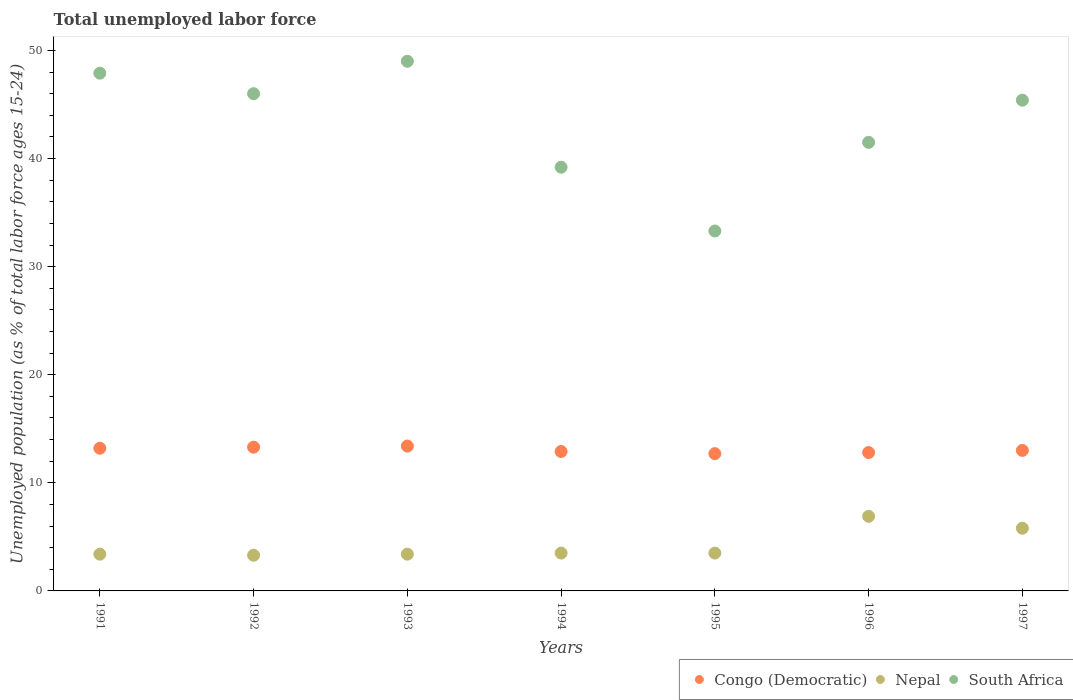How many different coloured dotlines are there?
Provide a succinct answer. 3. What is the percentage of unemployed population in in Congo (Democratic) in 1993?
Provide a short and direct response. 13.4. Across all years, what is the maximum percentage of unemployed population in in South Africa?
Offer a very short reply. 49. Across all years, what is the minimum percentage of unemployed population in in South Africa?
Give a very brief answer. 33.3. In which year was the percentage of unemployed population in in Congo (Democratic) maximum?
Provide a short and direct response. 1993. In which year was the percentage of unemployed population in in Nepal minimum?
Provide a short and direct response. 1992. What is the total percentage of unemployed population in in Nepal in the graph?
Make the answer very short. 29.8. What is the difference between the percentage of unemployed population in in Congo (Democratic) in 1991 and that in 1995?
Offer a terse response. 0.5. What is the difference between the percentage of unemployed population in in Nepal in 1992 and the percentage of unemployed population in in South Africa in 1996?
Your answer should be very brief. -38.2. What is the average percentage of unemployed population in in Congo (Democratic) per year?
Keep it short and to the point. 13.04. In the year 1991, what is the difference between the percentage of unemployed population in in Congo (Democratic) and percentage of unemployed population in in Nepal?
Offer a very short reply. 9.8. In how many years, is the percentage of unemployed population in in Nepal greater than 34 %?
Ensure brevity in your answer.  0. What is the ratio of the percentage of unemployed population in in South Africa in 1992 to that in 1993?
Ensure brevity in your answer.  0.94. Is the percentage of unemployed population in in Nepal in 1992 less than that in 1994?
Offer a terse response. Yes. What is the difference between the highest and the second highest percentage of unemployed population in in Nepal?
Your answer should be very brief. 1.1. What is the difference between the highest and the lowest percentage of unemployed population in in South Africa?
Provide a short and direct response. 15.7. In how many years, is the percentage of unemployed population in in Nepal greater than the average percentage of unemployed population in in Nepal taken over all years?
Offer a terse response. 2. Is it the case that in every year, the sum of the percentage of unemployed population in in Congo (Democratic) and percentage of unemployed population in in South Africa  is greater than the percentage of unemployed population in in Nepal?
Ensure brevity in your answer.  Yes. Is the percentage of unemployed population in in Nepal strictly less than the percentage of unemployed population in in Congo (Democratic) over the years?
Give a very brief answer. Yes. How many dotlines are there?
Your response must be concise. 3. Does the graph contain grids?
Your answer should be compact. No. Where does the legend appear in the graph?
Your response must be concise. Bottom right. What is the title of the graph?
Offer a very short reply. Total unemployed labor force. What is the label or title of the X-axis?
Ensure brevity in your answer.  Years. What is the label or title of the Y-axis?
Ensure brevity in your answer.  Unemployed population (as % of total labor force ages 15-24). What is the Unemployed population (as % of total labor force ages 15-24) in Congo (Democratic) in 1991?
Give a very brief answer. 13.2. What is the Unemployed population (as % of total labor force ages 15-24) of Nepal in 1991?
Provide a succinct answer. 3.4. What is the Unemployed population (as % of total labor force ages 15-24) of South Africa in 1991?
Offer a terse response. 47.9. What is the Unemployed population (as % of total labor force ages 15-24) in Congo (Democratic) in 1992?
Your answer should be compact. 13.3. What is the Unemployed population (as % of total labor force ages 15-24) of Nepal in 1992?
Your answer should be very brief. 3.3. What is the Unemployed population (as % of total labor force ages 15-24) of South Africa in 1992?
Ensure brevity in your answer.  46. What is the Unemployed population (as % of total labor force ages 15-24) of Congo (Democratic) in 1993?
Offer a very short reply. 13.4. What is the Unemployed population (as % of total labor force ages 15-24) of Nepal in 1993?
Your answer should be compact. 3.4. What is the Unemployed population (as % of total labor force ages 15-24) in Congo (Democratic) in 1994?
Your response must be concise. 12.9. What is the Unemployed population (as % of total labor force ages 15-24) in Nepal in 1994?
Keep it short and to the point. 3.5. What is the Unemployed population (as % of total labor force ages 15-24) in South Africa in 1994?
Keep it short and to the point. 39.2. What is the Unemployed population (as % of total labor force ages 15-24) in Congo (Democratic) in 1995?
Your response must be concise. 12.7. What is the Unemployed population (as % of total labor force ages 15-24) in South Africa in 1995?
Ensure brevity in your answer.  33.3. What is the Unemployed population (as % of total labor force ages 15-24) of Congo (Democratic) in 1996?
Provide a succinct answer. 12.8. What is the Unemployed population (as % of total labor force ages 15-24) of Nepal in 1996?
Ensure brevity in your answer.  6.9. What is the Unemployed population (as % of total labor force ages 15-24) in South Africa in 1996?
Provide a succinct answer. 41.5. What is the Unemployed population (as % of total labor force ages 15-24) in Nepal in 1997?
Provide a succinct answer. 5.8. What is the Unemployed population (as % of total labor force ages 15-24) of South Africa in 1997?
Make the answer very short. 45.4. Across all years, what is the maximum Unemployed population (as % of total labor force ages 15-24) in Congo (Democratic)?
Your answer should be compact. 13.4. Across all years, what is the maximum Unemployed population (as % of total labor force ages 15-24) of Nepal?
Keep it short and to the point. 6.9. Across all years, what is the minimum Unemployed population (as % of total labor force ages 15-24) of Congo (Democratic)?
Your response must be concise. 12.7. Across all years, what is the minimum Unemployed population (as % of total labor force ages 15-24) in Nepal?
Your answer should be very brief. 3.3. Across all years, what is the minimum Unemployed population (as % of total labor force ages 15-24) in South Africa?
Your response must be concise. 33.3. What is the total Unemployed population (as % of total labor force ages 15-24) in Congo (Democratic) in the graph?
Keep it short and to the point. 91.3. What is the total Unemployed population (as % of total labor force ages 15-24) in Nepal in the graph?
Offer a terse response. 29.8. What is the total Unemployed population (as % of total labor force ages 15-24) of South Africa in the graph?
Your response must be concise. 302.3. What is the difference between the Unemployed population (as % of total labor force ages 15-24) of Congo (Democratic) in 1991 and that in 1992?
Offer a terse response. -0.1. What is the difference between the Unemployed population (as % of total labor force ages 15-24) of South Africa in 1991 and that in 1992?
Provide a succinct answer. 1.9. What is the difference between the Unemployed population (as % of total labor force ages 15-24) of Nepal in 1991 and that in 1993?
Your answer should be very brief. 0. What is the difference between the Unemployed population (as % of total labor force ages 15-24) of Congo (Democratic) in 1991 and that in 1995?
Offer a very short reply. 0.5. What is the difference between the Unemployed population (as % of total labor force ages 15-24) in Nepal in 1991 and that in 1995?
Ensure brevity in your answer.  -0.1. What is the difference between the Unemployed population (as % of total labor force ages 15-24) in Congo (Democratic) in 1991 and that in 1996?
Make the answer very short. 0.4. What is the difference between the Unemployed population (as % of total labor force ages 15-24) in South Africa in 1991 and that in 1996?
Ensure brevity in your answer.  6.4. What is the difference between the Unemployed population (as % of total labor force ages 15-24) of Congo (Democratic) in 1991 and that in 1997?
Your answer should be very brief. 0.2. What is the difference between the Unemployed population (as % of total labor force ages 15-24) in South Africa in 1991 and that in 1997?
Give a very brief answer. 2.5. What is the difference between the Unemployed population (as % of total labor force ages 15-24) of Congo (Democratic) in 1992 and that in 1993?
Provide a succinct answer. -0.1. What is the difference between the Unemployed population (as % of total labor force ages 15-24) of Congo (Democratic) in 1992 and that in 1994?
Your answer should be compact. 0.4. What is the difference between the Unemployed population (as % of total labor force ages 15-24) in South Africa in 1992 and that in 1994?
Ensure brevity in your answer.  6.8. What is the difference between the Unemployed population (as % of total labor force ages 15-24) of Congo (Democratic) in 1992 and that in 1995?
Offer a terse response. 0.6. What is the difference between the Unemployed population (as % of total labor force ages 15-24) in Nepal in 1992 and that in 1995?
Your response must be concise. -0.2. What is the difference between the Unemployed population (as % of total labor force ages 15-24) of South Africa in 1992 and that in 1995?
Provide a succinct answer. 12.7. What is the difference between the Unemployed population (as % of total labor force ages 15-24) of Nepal in 1992 and that in 1996?
Your response must be concise. -3.6. What is the difference between the Unemployed population (as % of total labor force ages 15-24) in South Africa in 1992 and that in 1996?
Provide a short and direct response. 4.5. What is the difference between the Unemployed population (as % of total labor force ages 15-24) in South Africa in 1992 and that in 1997?
Your answer should be compact. 0.6. What is the difference between the Unemployed population (as % of total labor force ages 15-24) of Congo (Democratic) in 1993 and that in 1994?
Your answer should be very brief. 0.5. What is the difference between the Unemployed population (as % of total labor force ages 15-24) in Nepal in 1993 and that in 1994?
Offer a very short reply. -0.1. What is the difference between the Unemployed population (as % of total labor force ages 15-24) of South Africa in 1993 and that in 1994?
Give a very brief answer. 9.8. What is the difference between the Unemployed population (as % of total labor force ages 15-24) of Congo (Democratic) in 1993 and that in 1995?
Your response must be concise. 0.7. What is the difference between the Unemployed population (as % of total labor force ages 15-24) in Nepal in 1993 and that in 1995?
Provide a short and direct response. -0.1. What is the difference between the Unemployed population (as % of total labor force ages 15-24) of Congo (Democratic) in 1993 and that in 1996?
Your response must be concise. 0.6. What is the difference between the Unemployed population (as % of total labor force ages 15-24) of South Africa in 1993 and that in 1996?
Offer a very short reply. 7.5. What is the difference between the Unemployed population (as % of total labor force ages 15-24) of Nepal in 1994 and that in 1995?
Make the answer very short. 0. What is the difference between the Unemployed population (as % of total labor force ages 15-24) in Nepal in 1994 and that in 1996?
Keep it short and to the point. -3.4. What is the difference between the Unemployed population (as % of total labor force ages 15-24) of Congo (Democratic) in 1994 and that in 1997?
Offer a very short reply. -0.1. What is the difference between the Unemployed population (as % of total labor force ages 15-24) of South Africa in 1994 and that in 1997?
Keep it short and to the point. -6.2. What is the difference between the Unemployed population (as % of total labor force ages 15-24) of Congo (Democratic) in 1995 and that in 1996?
Provide a succinct answer. -0.1. What is the difference between the Unemployed population (as % of total labor force ages 15-24) in Nepal in 1995 and that in 1996?
Your answer should be very brief. -3.4. What is the difference between the Unemployed population (as % of total labor force ages 15-24) of Congo (Democratic) in 1995 and that in 1997?
Ensure brevity in your answer.  -0.3. What is the difference between the Unemployed population (as % of total labor force ages 15-24) in Nepal in 1995 and that in 1997?
Your answer should be compact. -2.3. What is the difference between the Unemployed population (as % of total labor force ages 15-24) of Nepal in 1996 and that in 1997?
Your answer should be very brief. 1.1. What is the difference between the Unemployed population (as % of total labor force ages 15-24) of South Africa in 1996 and that in 1997?
Offer a terse response. -3.9. What is the difference between the Unemployed population (as % of total labor force ages 15-24) in Congo (Democratic) in 1991 and the Unemployed population (as % of total labor force ages 15-24) in Nepal in 1992?
Provide a succinct answer. 9.9. What is the difference between the Unemployed population (as % of total labor force ages 15-24) of Congo (Democratic) in 1991 and the Unemployed population (as % of total labor force ages 15-24) of South Africa in 1992?
Provide a succinct answer. -32.8. What is the difference between the Unemployed population (as % of total labor force ages 15-24) in Nepal in 1991 and the Unemployed population (as % of total labor force ages 15-24) in South Africa in 1992?
Your answer should be compact. -42.6. What is the difference between the Unemployed population (as % of total labor force ages 15-24) in Congo (Democratic) in 1991 and the Unemployed population (as % of total labor force ages 15-24) in South Africa in 1993?
Your answer should be very brief. -35.8. What is the difference between the Unemployed population (as % of total labor force ages 15-24) in Nepal in 1991 and the Unemployed population (as % of total labor force ages 15-24) in South Africa in 1993?
Offer a very short reply. -45.6. What is the difference between the Unemployed population (as % of total labor force ages 15-24) of Congo (Democratic) in 1991 and the Unemployed population (as % of total labor force ages 15-24) of Nepal in 1994?
Keep it short and to the point. 9.7. What is the difference between the Unemployed population (as % of total labor force ages 15-24) of Nepal in 1991 and the Unemployed population (as % of total labor force ages 15-24) of South Africa in 1994?
Keep it short and to the point. -35.8. What is the difference between the Unemployed population (as % of total labor force ages 15-24) in Congo (Democratic) in 1991 and the Unemployed population (as % of total labor force ages 15-24) in South Africa in 1995?
Your response must be concise. -20.1. What is the difference between the Unemployed population (as % of total labor force ages 15-24) of Nepal in 1991 and the Unemployed population (as % of total labor force ages 15-24) of South Africa in 1995?
Offer a very short reply. -29.9. What is the difference between the Unemployed population (as % of total labor force ages 15-24) of Congo (Democratic) in 1991 and the Unemployed population (as % of total labor force ages 15-24) of Nepal in 1996?
Your response must be concise. 6.3. What is the difference between the Unemployed population (as % of total labor force ages 15-24) of Congo (Democratic) in 1991 and the Unemployed population (as % of total labor force ages 15-24) of South Africa in 1996?
Provide a succinct answer. -28.3. What is the difference between the Unemployed population (as % of total labor force ages 15-24) in Nepal in 1991 and the Unemployed population (as % of total labor force ages 15-24) in South Africa in 1996?
Provide a succinct answer. -38.1. What is the difference between the Unemployed population (as % of total labor force ages 15-24) of Congo (Democratic) in 1991 and the Unemployed population (as % of total labor force ages 15-24) of South Africa in 1997?
Keep it short and to the point. -32.2. What is the difference between the Unemployed population (as % of total labor force ages 15-24) in Nepal in 1991 and the Unemployed population (as % of total labor force ages 15-24) in South Africa in 1997?
Your answer should be very brief. -42. What is the difference between the Unemployed population (as % of total labor force ages 15-24) in Congo (Democratic) in 1992 and the Unemployed population (as % of total labor force ages 15-24) in Nepal in 1993?
Give a very brief answer. 9.9. What is the difference between the Unemployed population (as % of total labor force ages 15-24) in Congo (Democratic) in 1992 and the Unemployed population (as % of total labor force ages 15-24) in South Africa in 1993?
Offer a terse response. -35.7. What is the difference between the Unemployed population (as % of total labor force ages 15-24) of Nepal in 1992 and the Unemployed population (as % of total labor force ages 15-24) of South Africa in 1993?
Give a very brief answer. -45.7. What is the difference between the Unemployed population (as % of total labor force ages 15-24) of Congo (Democratic) in 1992 and the Unemployed population (as % of total labor force ages 15-24) of Nepal in 1994?
Your answer should be very brief. 9.8. What is the difference between the Unemployed population (as % of total labor force ages 15-24) of Congo (Democratic) in 1992 and the Unemployed population (as % of total labor force ages 15-24) of South Africa in 1994?
Make the answer very short. -25.9. What is the difference between the Unemployed population (as % of total labor force ages 15-24) of Nepal in 1992 and the Unemployed population (as % of total labor force ages 15-24) of South Africa in 1994?
Provide a short and direct response. -35.9. What is the difference between the Unemployed population (as % of total labor force ages 15-24) of Congo (Democratic) in 1992 and the Unemployed population (as % of total labor force ages 15-24) of South Africa in 1995?
Ensure brevity in your answer.  -20. What is the difference between the Unemployed population (as % of total labor force ages 15-24) of Nepal in 1992 and the Unemployed population (as % of total labor force ages 15-24) of South Africa in 1995?
Keep it short and to the point. -30. What is the difference between the Unemployed population (as % of total labor force ages 15-24) in Congo (Democratic) in 1992 and the Unemployed population (as % of total labor force ages 15-24) in South Africa in 1996?
Ensure brevity in your answer.  -28.2. What is the difference between the Unemployed population (as % of total labor force ages 15-24) of Nepal in 1992 and the Unemployed population (as % of total labor force ages 15-24) of South Africa in 1996?
Ensure brevity in your answer.  -38.2. What is the difference between the Unemployed population (as % of total labor force ages 15-24) in Congo (Democratic) in 1992 and the Unemployed population (as % of total labor force ages 15-24) in South Africa in 1997?
Give a very brief answer. -32.1. What is the difference between the Unemployed population (as % of total labor force ages 15-24) of Nepal in 1992 and the Unemployed population (as % of total labor force ages 15-24) of South Africa in 1997?
Your answer should be compact. -42.1. What is the difference between the Unemployed population (as % of total labor force ages 15-24) of Congo (Democratic) in 1993 and the Unemployed population (as % of total labor force ages 15-24) of Nepal in 1994?
Your answer should be very brief. 9.9. What is the difference between the Unemployed population (as % of total labor force ages 15-24) of Congo (Democratic) in 1993 and the Unemployed population (as % of total labor force ages 15-24) of South Africa in 1994?
Provide a succinct answer. -25.8. What is the difference between the Unemployed population (as % of total labor force ages 15-24) in Nepal in 1993 and the Unemployed population (as % of total labor force ages 15-24) in South Africa in 1994?
Keep it short and to the point. -35.8. What is the difference between the Unemployed population (as % of total labor force ages 15-24) in Congo (Democratic) in 1993 and the Unemployed population (as % of total labor force ages 15-24) in Nepal in 1995?
Your answer should be very brief. 9.9. What is the difference between the Unemployed population (as % of total labor force ages 15-24) in Congo (Democratic) in 1993 and the Unemployed population (as % of total labor force ages 15-24) in South Africa in 1995?
Offer a very short reply. -19.9. What is the difference between the Unemployed population (as % of total labor force ages 15-24) of Nepal in 1993 and the Unemployed population (as % of total labor force ages 15-24) of South Africa in 1995?
Offer a terse response. -29.9. What is the difference between the Unemployed population (as % of total labor force ages 15-24) of Congo (Democratic) in 1993 and the Unemployed population (as % of total labor force ages 15-24) of South Africa in 1996?
Give a very brief answer. -28.1. What is the difference between the Unemployed population (as % of total labor force ages 15-24) of Nepal in 1993 and the Unemployed population (as % of total labor force ages 15-24) of South Africa in 1996?
Your response must be concise. -38.1. What is the difference between the Unemployed population (as % of total labor force ages 15-24) in Congo (Democratic) in 1993 and the Unemployed population (as % of total labor force ages 15-24) in Nepal in 1997?
Provide a succinct answer. 7.6. What is the difference between the Unemployed population (as % of total labor force ages 15-24) in Congo (Democratic) in 1993 and the Unemployed population (as % of total labor force ages 15-24) in South Africa in 1997?
Your response must be concise. -32. What is the difference between the Unemployed population (as % of total labor force ages 15-24) of Nepal in 1993 and the Unemployed population (as % of total labor force ages 15-24) of South Africa in 1997?
Ensure brevity in your answer.  -42. What is the difference between the Unemployed population (as % of total labor force ages 15-24) in Congo (Democratic) in 1994 and the Unemployed population (as % of total labor force ages 15-24) in South Africa in 1995?
Provide a short and direct response. -20.4. What is the difference between the Unemployed population (as % of total labor force ages 15-24) in Nepal in 1994 and the Unemployed population (as % of total labor force ages 15-24) in South Africa in 1995?
Give a very brief answer. -29.8. What is the difference between the Unemployed population (as % of total labor force ages 15-24) of Congo (Democratic) in 1994 and the Unemployed population (as % of total labor force ages 15-24) of Nepal in 1996?
Keep it short and to the point. 6. What is the difference between the Unemployed population (as % of total labor force ages 15-24) in Congo (Democratic) in 1994 and the Unemployed population (as % of total labor force ages 15-24) in South Africa in 1996?
Your answer should be very brief. -28.6. What is the difference between the Unemployed population (as % of total labor force ages 15-24) of Nepal in 1994 and the Unemployed population (as % of total labor force ages 15-24) of South Africa in 1996?
Offer a terse response. -38. What is the difference between the Unemployed population (as % of total labor force ages 15-24) of Congo (Democratic) in 1994 and the Unemployed population (as % of total labor force ages 15-24) of South Africa in 1997?
Give a very brief answer. -32.5. What is the difference between the Unemployed population (as % of total labor force ages 15-24) in Nepal in 1994 and the Unemployed population (as % of total labor force ages 15-24) in South Africa in 1997?
Offer a very short reply. -41.9. What is the difference between the Unemployed population (as % of total labor force ages 15-24) in Congo (Democratic) in 1995 and the Unemployed population (as % of total labor force ages 15-24) in Nepal in 1996?
Provide a succinct answer. 5.8. What is the difference between the Unemployed population (as % of total labor force ages 15-24) of Congo (Democratic) in 1995 and the Unemployed population (as % of total labor force ages 15-24) of South Africa in 1996?
Offer a very short reply. -28.8. What is the difference between the Unemployed population (as % of total labor force ages 15-24) in Nepal in 1995 and the Unemployed population (as % of total labor force ages 15-24) in South Africa in 1996?
Provide a short and direct response. -38. What is the difference between the Unemployed population (as % of total labor force ages 15-24) of Congo (Democratic) in 1995 and the Unemployed population (as % of total labor force ages 15-24) of Nepal in 1997?
Provide a short and direct response. 6.9. What is the difference between the Unemployed population (as % of total labor force ages 15-24) of Congo (Democratic) in 1995 and the Unemployed population (as % of total labor force ages 15-24) of South Africa in 1997?
Offer a terse response. -32.7. What is the difference between the Unemployed population (as % of total labor force ages 15-24) of Nepal in 1995 and the Unemployed population (as % of total labor force ages 15-24) of South Africa in 1997?
Give a very brief answer. -41.9. What is the difference between the Unemployed population (as % of total labor force ages 15-24) of Congo (Democratic) in 1996 and the Unemployed population (as % of total labor force ages 15-24) of South Africa in 1997?
Provide a short and direct response. -32.6. What is the difference between the Unemployed population (as % of total labor force ages 15-24) in Nepal in 1996 and the Unemployed population (as % of total labor force ages 15-24) in South Africa in 1997?
Your response must be concise. -38.5. What is the average Unemployed population (as % of total labor force ages 15-24) of Congo (Democratic) per year?
Your answer should be very brief. 13.04. What is the average Unemployed population (as % of total labor force ages 15-24) in Nepal per year?
Your answer should be very brief. 4.26. What is the average Unemployed population (as % of total labor force ages 15-24) in South Africa per year?
Ensure brevity in your answer.  43.19. In the year 1991, what is the difference between the Unemployed population (as % of total labor force ages 15-24) in Congo (Democratic) and Unemployed population (as % of total labor force ages 15-24) in Nepal?
Your answer should be compact. 9.8. In the year 1991, what is the difference between the Unemployed population (as % of total labor force ages 15-24) of Congo (Democratic) and Unemployed population (as % of total labor force ages 15-24) of South Africa?
Offer a terse response. -34.7. In the year 1991, what is the difference between the Unemployed population (as % of total labor force ages 15-24) of Nepal and Unemployed population (as % of total labor force ages 15-24) of South Africa?
Your response must be concise. -44.5. In the year 1992, what is the difference between the Unemployed population (as % of total labor force ages 15-24) in Congo (Democratic) and Unemployed population (as % of total labor force ages 15-24) in Nepal?
Offer a very short reply. 10. In the year 1992, what is the difference between the Unemployed population (as % of total labor force ages 15-24) of Congo (Democratic) and Unemployed population (as % of total labor force ages 15-24) of South Africa?
Ensure brevity in your answer.  -32.7. In the year 1992, what is the difference between the Unemployed population (as % of total labor force ages 15-24) of Nepal and Unemployed population (as % of total labor force ages 15-24) of South Africa?
Provide a succinct answer. -42.7. In the year 1993, what is the difference between the Unemployed population (as % of total labor force ages 15-24) of Congo (Democratic) and Unemployed population (as % of total labor force ages 15-24) of South Africa?
Offer a terse response. -35.6. In the year 1993, what is the difference between the Unemployed population (as % of total labor force ages 15-24) of Nepal and Unemployed population (as % of total labor force ages 15-24) of South Africa?
Offer a very short reply. -45.6. In the year 1994, what is the difference between the Unemployed population (as % of total labor force ages 15-24) of Congo (Democratic) and Unemployed population (as % of total labor force ages 15-24) of Nepal?
Your answer should be very brief. 9.4. In the year 1994, what is the difference between the Unemployed population (as % of total labor force ages 15-24) of Congo (Democratic) and Unemployed population (as % of total labor force ages 15-24) of South Africa?
Your answer should be compact. -26.3. In the year 1994, what is the difference between the Unemployed population (as % of total labor force ages 15-24) of Nepal and Unemployed population (as % of total labor force ages 15-24) of South Africa?
Keep it short and to the point. -35.7. In the year 1995, what is the difference between the Unemployed population (as % of total labor force ages 15-24) of Congo (Democratic) and Unemployed population (as % of total labor force ages 15-24) of Nepal?
Your answer should be very brief. 9.2. In the year 1995, what is the difference between the Unemployed population (as % of total labor force ages 15-24) in Congo (Democratic) and Unemployed population (as % of total labor force ages 15-24) in South Africa?
Provide a succinct answer. -20.6. In the year 1995, what is the difference between the Unemployed population (as % of total labor force ages 15-24) of Nepal and Unemployed population (as % of total labor force ages 15-24) of South Africa?
Give a very brief answer. -29.8. In the year 1996, what is the difference between the Unemployed population (as % of total labor force ages 15-24) in Congo (Democratic) and Unemployed population (as % of total labor force ages 15-24) in Nepal?
Ensure brevity in your answer.  5.9. In the year 1996, what is the difference between the Unemployed population (as % of total labor force ages 15-24) of Congo (Democratic) and Unemployed population (as % of total labor force ages 15-24) of South Africa?
Make the answer very short. -28.7. In the year 1996, what is the difference between the Unemployed population (as % of total labor force ages 15-24) of Nepal and Unemployed population (as % of total labor force ages 15-24) of South Africa?
Make the answer very short. -34.6. In the year 1997, what is the difference between the Unemployed population (as % of total labor force ages 15-24) in Congo (Democratic) and Unemployed population (as % of total labor force ages 15-24) in South Africa?
Offer a terse response. -32.4. In the year 1997, what is the difference between the Unemployed population (as % of total labor force ages 15-24) in Nepal and Unemployed population (as % of total labor force ages 15-24) in South Africa?
Provide a short and direct response. -39.6. What is the ratio of the Unemployed population (as % of total labor force ages 15-24) of Nepal in 1991 to that in 1992?
Offer a very short reply. 1.03. What is the ratio of the Unemployed population (as % of total labor force ages 15-24) of South Africa in 1991 to that in 1992?
Your answer should be compact. 1.04. What is the ratio of the Unemployed population (as % of total labor force ages 15-24) in Congo (Democratic) in 1991 to that in 1993?
Give a very brief answer. 0.99. What is the ratio of the Unemployed population (as % of total labor force ages 15-24) in South Africa in 1991 to that in 1993?
Give a very brief answer. 0.98. What is the ratio of the Unemployed population (as % of total labor force ages 15-24) of Congo (Democratic) in 1991 to that in 1994?
Make the answer very short. 1.02. What is the ratio of the Unemployed population (as % of total labor force ages 15-24) in Nepal in 1991 to that in 1994?
Offer a very short reply. 0.97. What is the ratio of the Unemployed population (as % of total labor force ages 15-24) in South Africa in 1991 to that in 1994?
Ensure brevity in your answer.  1.22. What is the ratio of the Unemployed population (as % of total labor force ages 15-24) of Congo (Democratic) in 1991 to that in 1995?
Keep it short and to the point. 1.04. What is the ratio of the Unemployed population (as % of total labor force ages 15-24) of Nepal in 1991 to that in 1995?
Your answer should be very brief. 0.97. What is the ratio of the Unemployed population (as % of total labor force ages 15-24) of South Africa in 1991 to that in 1995?
Offer a very short reply. 1.44. What is the ratio of the Unemployed population (as % of total labor force ages 15-24) in Congo (Democratic) in 1991 to that in 1996?
Give a very brief answer. 1.03. What is the ratio of the Unemployed population (as % of total labor force ages 15-24) of Nepal in 1991 to that in 1996?
Your answer should be very brief. 0.49. What is the ratio of the Unemployed population (as % of total labor force ages 15-24) in South Africa in 1991 to that in 1996?
Keep it short and to the point. 1.15. What is the ratio of the Unemployed population (as % of total labor force ages 15-24) in Congo (Democratic) in 1991 to that in 1997?
Provide a succinct answer. 1.02. What is the ratio of the Unemployed population (as % of total labor force ages 15-24) in Nepal in 1991 to that in 1997?
Offer a very short reply. 0.59. What is the ratio of the Unemployed population (as % of total labor force ages 15-24) of South Africa in 1991 to that in 1997?
Make the answer very short. 1.06. What is the ratio of the Unemployed population (as % of total labor force ages 15-24) in Nepal in 1992 to that in 1993?
Give a very brief answer. 0.97. What is the ratio of the Unemployed population (as % of total labor force ages 15-24) of South Africa in 1992 to that in 1993?
Ensure brevity in your answer.  0.94. What is the ratio of the Unemployed population (as % of total labor force ages 15-24) in Congo (Democratic) in 1992 to that in 1994?
Your answer should be very brief. 1.03. What is the ratio of the Unemployed population (as % of total labor force ages 15-24) in Nepal in 1992 to that in 1994?
Your answer should be compact. 0.94. What is the ratio of the Unemployed population (as % of total labor force ages 15-24) in South Africa in 1992 to that in 1994?
Ensure brevity in your answer.  1.17. What is the ratio of the Unemployed population (as % of total labor force ages 15-24) in Congo (Democratic) in 1992 to that in 1995?
Ensure brevity in your answer.  1.05. What is the ratio of the Unemployed population (as % of total labor force ages 15-24) in Nepal in 1992 to that in 1995?
Keep it short and to the point. 0.94. What is the ratio of the Unemployed population (as % of total labor force ages 15-24) in South Africa in 1992 to that in 1995?
Give a very brief answer. 1.38. What is the ratio of the Unemployed population (as % of total labor force ages 15-24) in Congo (Democratic) in 1992 to that in 1996?
Your response must be concise. 1.04. What is the ratio of the Unemployed population (as % of total labor force ages 15-24) in Nepal in 1992 to that in 1996?
Keep it short and to the point. 0.48. What is the ratio of the Unemployed population (as % of total labor force ages 15-24) in South Africa in 1992 to that in 1996?
Make the answer very short. 1.11. What is the ratio of the Unemployed population (as % of total labor force ages 15-24) in Congo (Democratic) in 1992 to that in 1997?
Give a very brief answer. 1.02. What is the ratio of the Unemployed population (as % of total labor force ages 15-24) of Nepal in 1992 to that in 1997?
Your answer should be very brief. 0.57. What is the ratio of the Unemployed population (as % of total labor force ages 15-24) of South Africa in 1992 to that in 1997?
Offer a very short reply. 1.01. What is the ratio of the Unemployed population (as % of total labor force ages 15-24) of Congo (Democratic) in 1993 to that in 1994?
Provide a short and direct response. 1.04. What is the ratio of the Unemployed population (as % of total labor force ages 15-24) in Nepal in 1993 to that in 1994?
Give a very brief answer. 0.97. What is the ratio of the Unemployed population (as % of total labor force ages 15-24) in Congo (Democratic) in 1993 to that in 1995?
Ensure brevity in your answer.  1.06. What is the ratio of the Unemployed population (as % of total labor force ages 15-24) of Nepal in 1993 to that in 1995?
Provide a succinct answer. 0.97. What is the ratio of the Unemployed population (as % of total labor force ages 15-24) in South Africa in 1993 to that in 1995?
Your answer should be very brief. 1.47. What is the ratio of the Unemployed population (as % of total labor force ages 15-24) of Congo (Democratic) in 1993 to that in 1996?
Keep it short and to the point. 1.05. What is the ratio of the Unemployed population (as % of total labor force ages 15-24) in Nepal in 1993 to that in 1996?
Give a very brief answer. 0.49. What is the ratio of the Unemployed population (as % of total labor force ages 15-24) in South Africa in 1993 to that in 1996?
Provide a short and direct response. 1.18. What is the ratio of the Unemployed population (as % of total labor force ages 15-24) of Congo (Democratic) in 1993 to that in 1997?
Offer a very short reply. 1.03. What is the ratio of the Unemployed population (as % of total labor force ages 15-24) of Nepal in 1993 to that in 1997?
Your answer should be very brief. 0.59. What is the ratio of the Unemployed population (as % of total labor force ages 15-24) in South Africa in 1993 to that in 1997?
Make the answer very short. 1.08. What is the ratio of the Unemployed population (as % of total labor force ages 15-24) in Congo (Democratic) in 1994 to that in 1995?
Keep it short and to the point. 1.02. What is the ratio of the Unemployed population (as % of total labor force ages 15-24) of South Africa in 1994 to that in 1995?
Provide a succinct answer. 1.18. What is the ratio of the Unemployed population (as % of total labor force ages 15-24) in Nepal in 1994 to that in 1996?
Offer a very short reply. 0.51. What is the ratio of the Unemployed population (as % of total labor force ages 15-24) of South Africa in 1994 to that in 1996?
Provide a short and direct response. 0.94. What is the ratio of the Unemployed population (as % of total labor force ages 15-24) in Congo (Democratic) in 1994 to that in 1997?
Make the answer very short. 0.99. What is the ratio of the Unemployed population (as % of total labor force ages 15-24) in Nepal in 1994 to that in 1997?
Ensure brevity in your answer.  0.6. What is the ratio of the Unemployed population (as % of total labor force ages 15-24) of South Africa in 1994 to that in 1997?
Your response must be concise. 0.86. What is the ratio of the Unemployed population (as % of total labor force ages 15-24) in Congo (Democratic) in 1995 to that in 1996?
Offer a very short reply. 0.99. What is the ratio of the Unemployed population (as % of total labor force ages 15-24) in Nepal in 1995 to that in 1996?
Offer a terse response. 0.51. What is the ratio of the Unemployed population (as % of total labor force ages 15-24) in South Africa in 1995 to that in 1996?
Provide a succinct answer. 0.8. What is the ratio of the Unemployed population (as % of total labor force ages 15-24) of Congo (Democratic) in 1995 to that in 1997?
Your answer should be very brief. 0.98. What is the ratio of the Unemployed population (as % of total labor force ages 15-24) in Nepal in 1995 to that in 1997?
Offer a very short reply. 0.6. What is the ratio of the Unemployed population (as % of total labor force ages 15-24) in South Africa in 1995 to that in 1997?
Your answer should be compact. 0.73. What is the ratio of the Unemployed population (as % of total labor force ages 15-24) of Congo (Democratic) in 1996 to that in 1997?
Offer a very short reply. 0.98. What is the ratio of the Unemployed population (as % of total labor force ages 15-24) of Nepal in 1996 to that in 1997?
Make the answer very short. 1.19. What is the ratio of the Unemployed population (as % of total labor force ages 15-24) in South Africa in 1996 to that in 1997?
Provide a succinct answer. 0.91. What is the difference between the highest and the second highest Unemployed population (as % of total labor force ages 15-24) in Nepal?
Keep it short and to the point. 1.1. What is the difference between the highest and the second highest Unemployed population (as % of total labor force ages 15-24) of South Africa?
Offer a very short reply. 1.1. What is the difference between the highest and the lowest Unemployed population (as % of total labor force ages 15-24) in South Africa?
Ensure brevity in your answer.  15.7. 